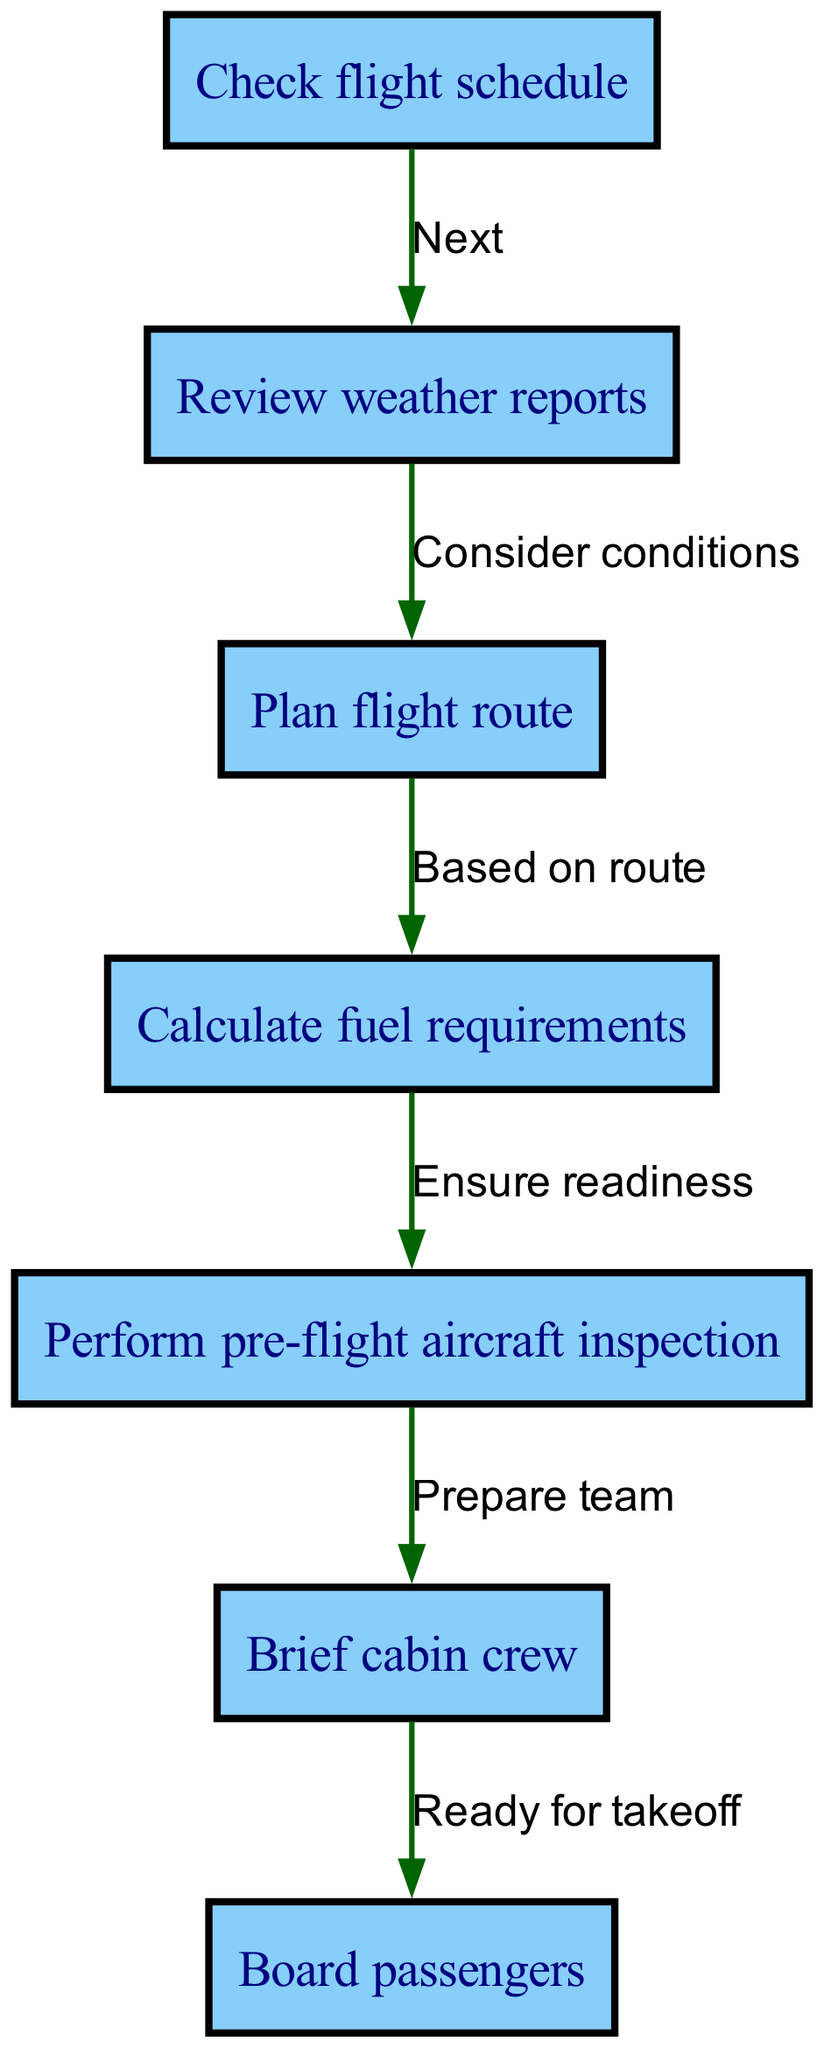What is the first step in the flight preparation process? The diagram starts with "Check flight schedule," indicating it's the first step pilots need to take before any other actions.
Answer: Check flight schedule How many nodes are in the flow chart? The flow chart displays a total of 7 nodes enumerating the different steps involved in the flight preparation process.
Answer: 7 What are the last two steps in the preparation process? The last two steps shown in the diagram are "Brief cabin crew" followed by "Board passengers," which happen consecutively before takeoff.
Answer: Brief cabin crew, Board passengers What is the relationship between reviewing weather reports and planning the flight route? The flow chart shows a direct connection where "Review weather reports" leads to "Plan flight route," meaning that the weather conditions should be considered when planning the route.
Answer: Consider conditions What ensures the aircraft is ready for the flight? The step "Calculate fuel requirements" comes before "Perform pre-flight aircraft inspection," indicating that calculating how much fuel is needed ensures that the aircraft is ready.
Answer: Ensure readiness What does the pilot do after checking the flight schedule? Following "Check flight schedule," the next step to perform is "Review weather reports," establishing the necessary information on weather conditions for flight preparation.
Answer: Review weather reports What is the primary purpose of the "Brief cabin crew" node? This step prepares the cabin crew for the flight, ensuring they understand their roles and tasks before boarding.
Answer: Prepare team What does the flow from "Calculate fuel requirements" to "Perform pre-flight aircraft inspection" represent? This flow indicates that once the pilot calculates the required fuel based on the planned route, it leads to ensuring the aircraft is physically inspected and ready for the flight.
Answer: Ensure readiness 